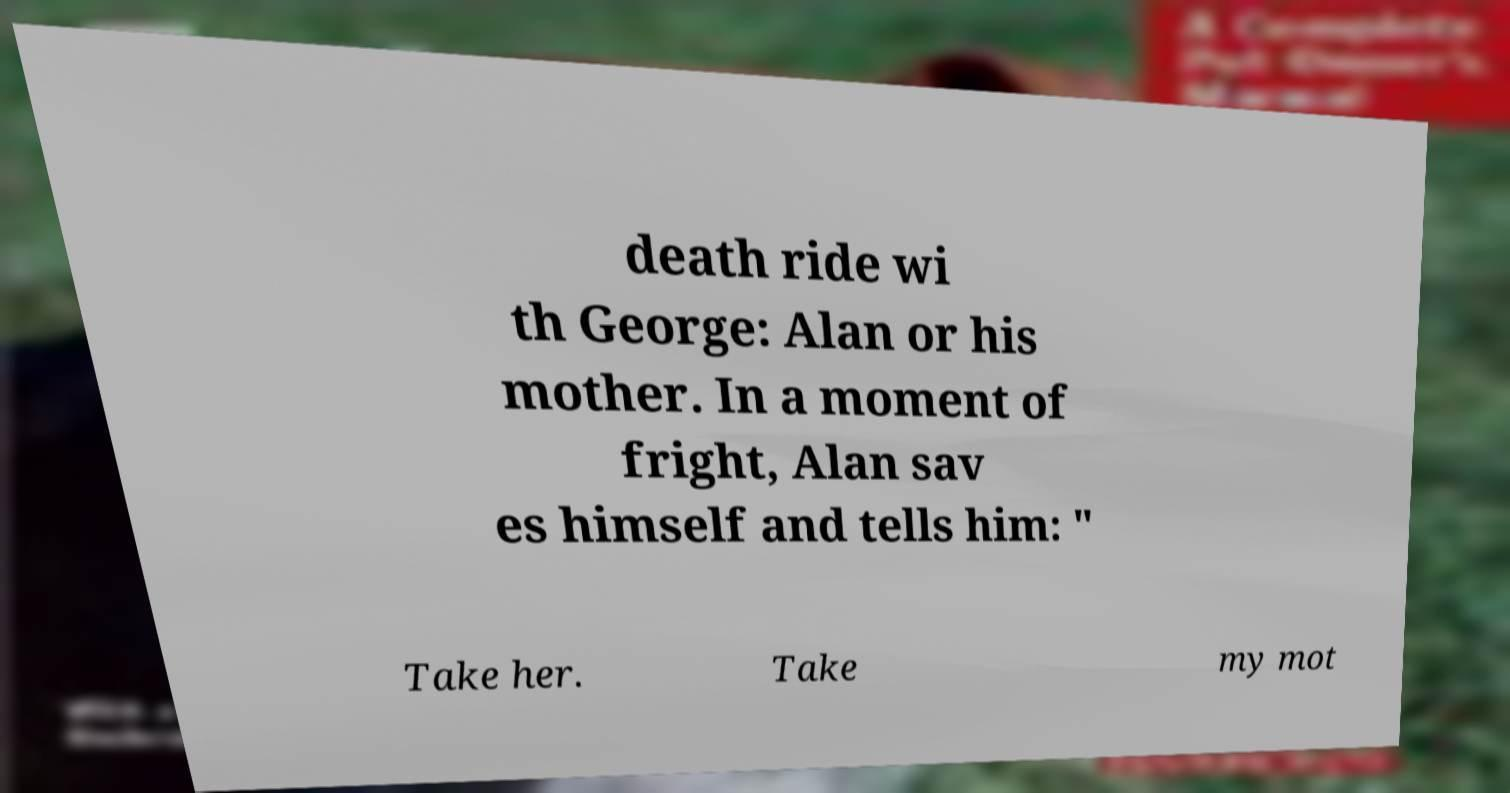There's text embedded in this image that I need extracted. Can you transcribe it verbatim? death ride wi th George: Alan or his mother. In a moment of fright, Alan sav es himself and tells him: " Take her. Take my mot 